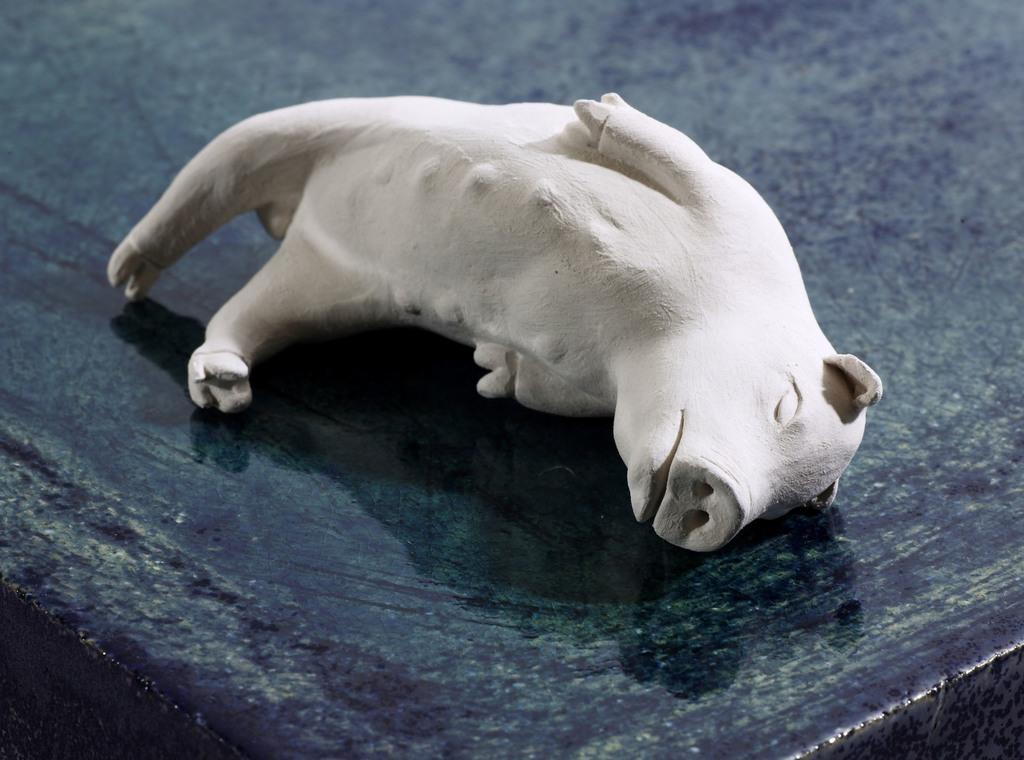What is the main object in the image? There is a table in the image. What is on the table? There is a pig toy on the table. What type of theory is being discussed by the pig toy in the image? There is no discussion or theory present in the image; it is a static image of a table with a pig toy on it. 